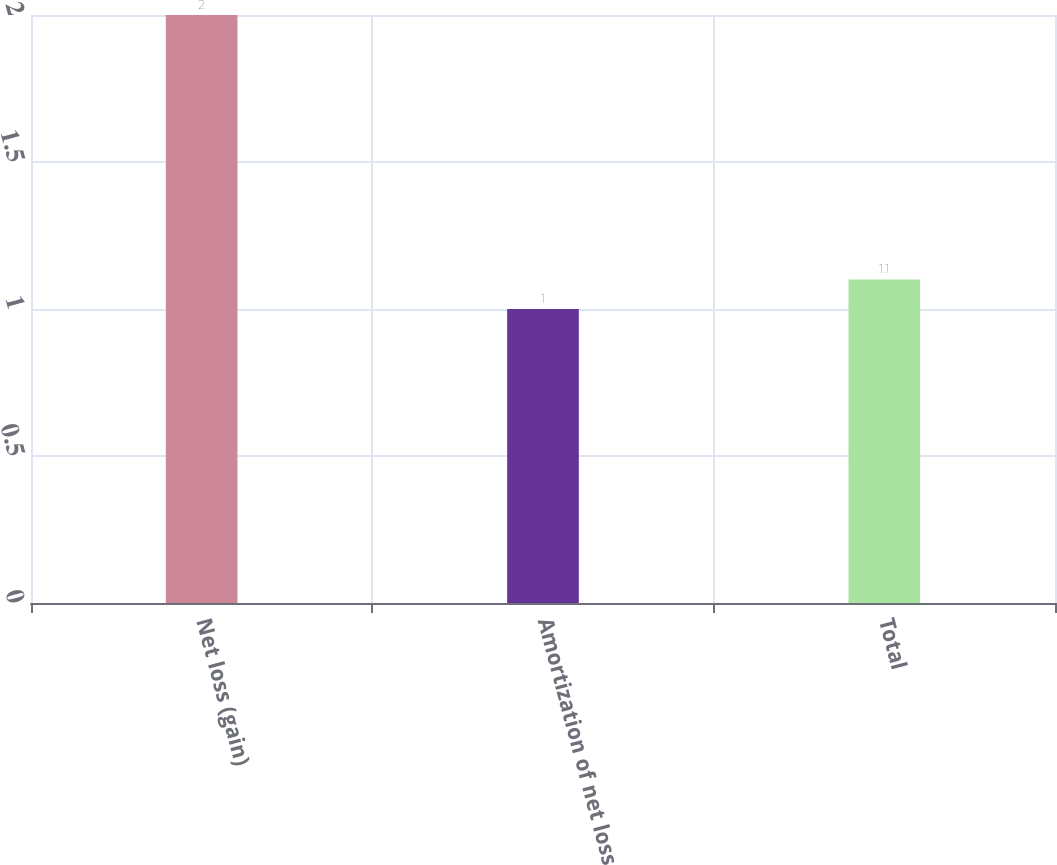Convert chart. <chart><loc_0><loc_0><loc_500><loc_500><bar_chart><fcel>Net loss (gain)<fcel>Amortization of net loss<fcel>Total<nl><fcel>2<fcel>1<fcel>1.1<nl></chart> 